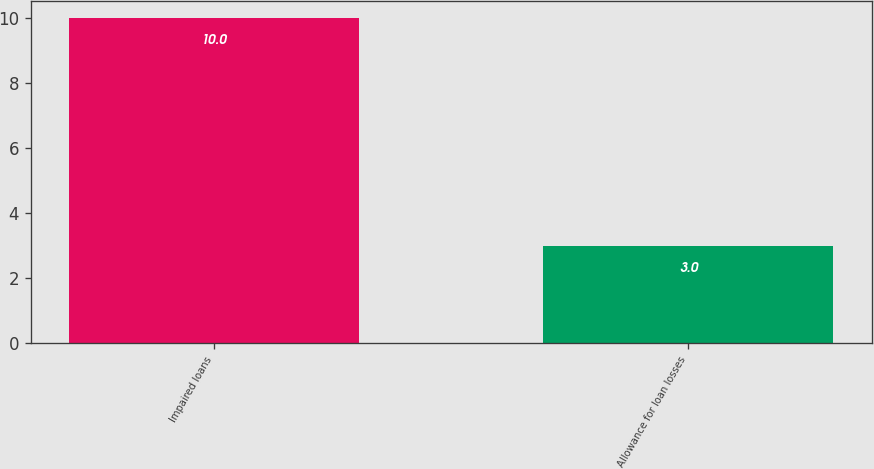<chart> <loc_0><loc_0><loc_500><loc_500><bar_chart><fcel>Impaired loans<fcel>Allowance for loan losses<nl><fcel>10<fcel>3<nl></chart> 